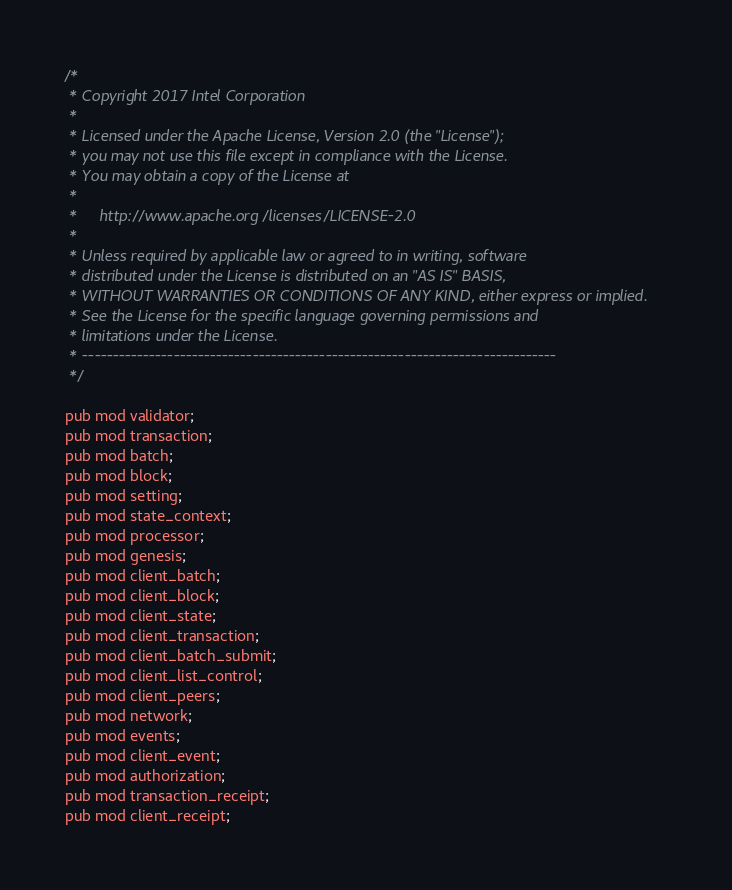<code> <loc_0><loc_0><loc_500><loc_500><_Rust_>/*
 * Copyright 2017 Intel Corporation
 *
 * Licensed under the Apache License, Version 2.0 (the "License");
 * you may not use this file except in compliance with the License.
 * You may obtain a copy of the License at
 *
 *     http://www.apache.org/licenses/LICENSE-2.0
 *
 * Unless required by applicable law or agreed to in writing, software
 * distributed under the License is distributed on an "AS IS" BASIS,
 * WITHOUT WARRANTIES OR CONDITIONS OF ANY KIND, either express or implied.
 * See the License for the specific language governing permissions and
 * limitations under the License.
 * ------------------------------------------------------------------------------
 */

pub mod validator;
pub mod transaction;
pub mod batch;
pub mod block;
pub mod setting;
pub mod state_context;
pub mod processor;
pub mod genesis;
pub mod client_batch;
pub mod client_block;
pub mod client_state;
pub mod client_transaction;
pub mod client_batch_submit;
pub mod client_list_control;
pub mod client_peers;
pub mod network;
pub mod events;
pub mod client_event;
pub mod authorization;
pub mod transaction_receipt;
pub mod client_receipt;
</code> 